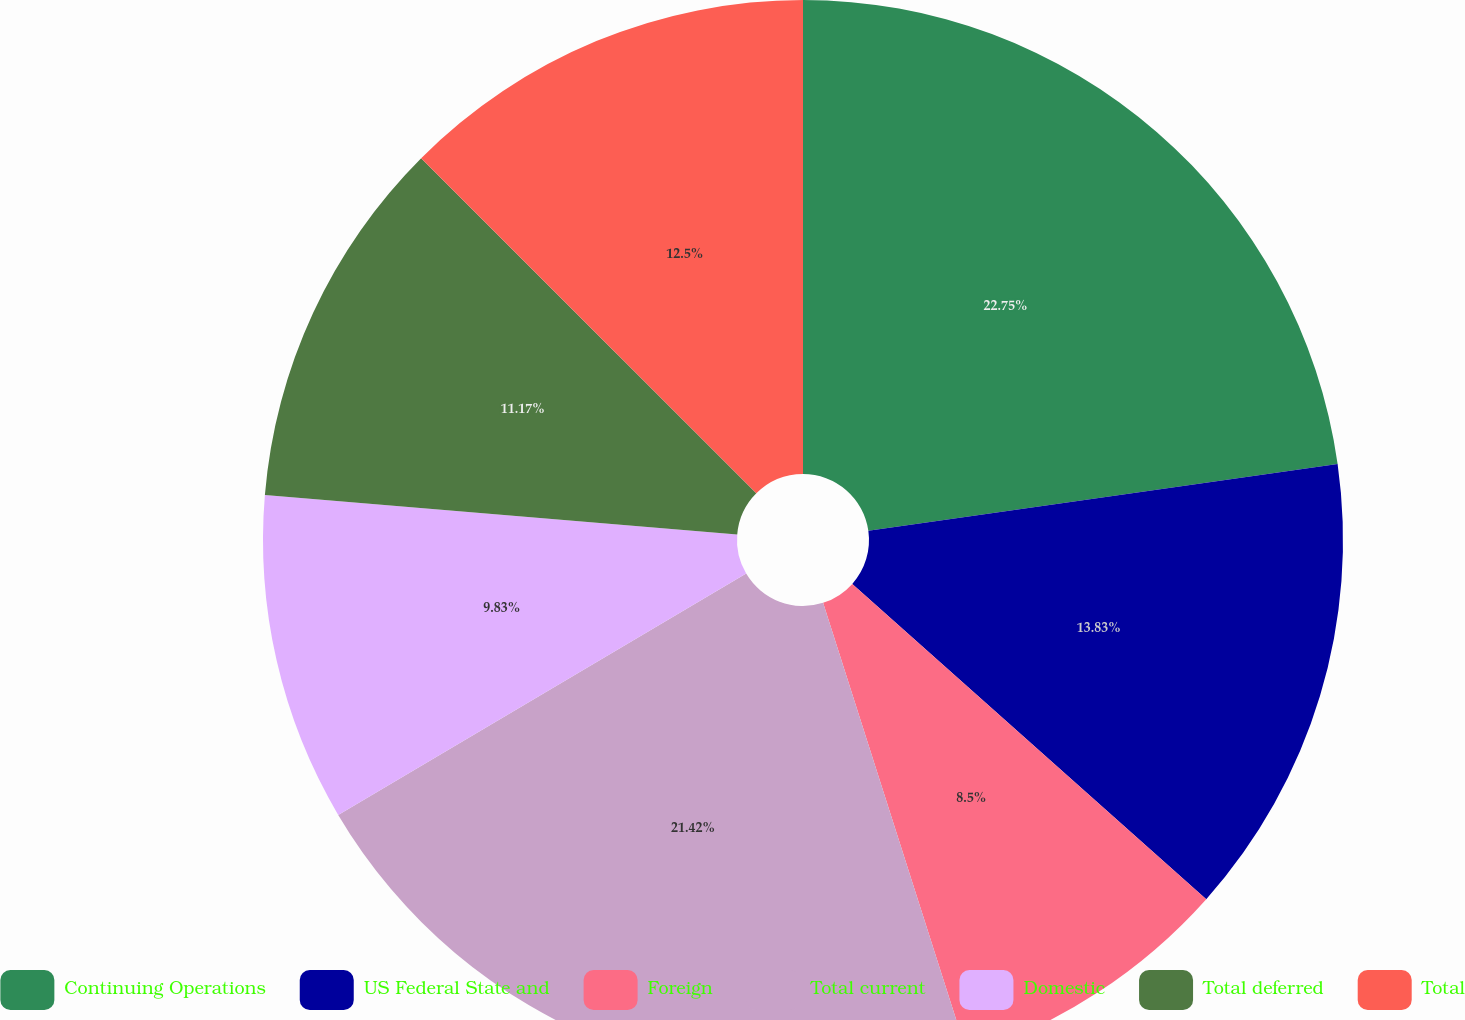Convert chart to OTSL. <chart><loc_0><loc_0><loc_500><loc_500><pie_chart><fcel>Continuing Operations<fcel>US Federal State and<fcel>Foreign<fcel>Total current<fcel>Domestic<fcel>Total deferred<fcel>Total<nl><fcel>22.75%<fcel>13.83%<fcel>8.5%<fcel>21.42%<fcel>9.83%<fcel>11.17%<fcel>12.5%<nl></chart> 